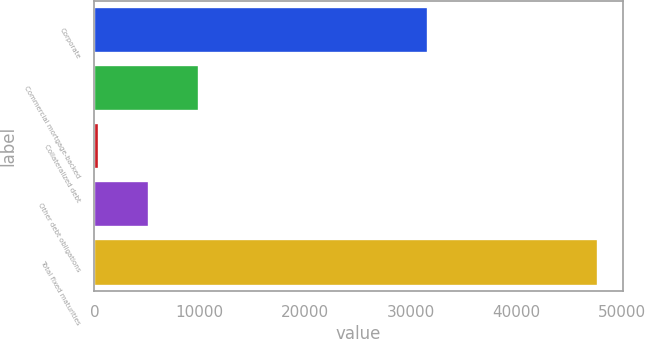Convert chart to OTSL. <chart><loc_0><loc_0><loc_500><loc_500><bar_chart><fcel>Corporate<fcel>Commercial mortgage-backed<fcel>Collateralized debt<fcel>Other debt obligations<fcel>Total fixed maturities<nl><fcel>31615.4<fcel>9886.1<fcel>428.8<fcel>5157.45<fcel>47715.3<nl></chart> 